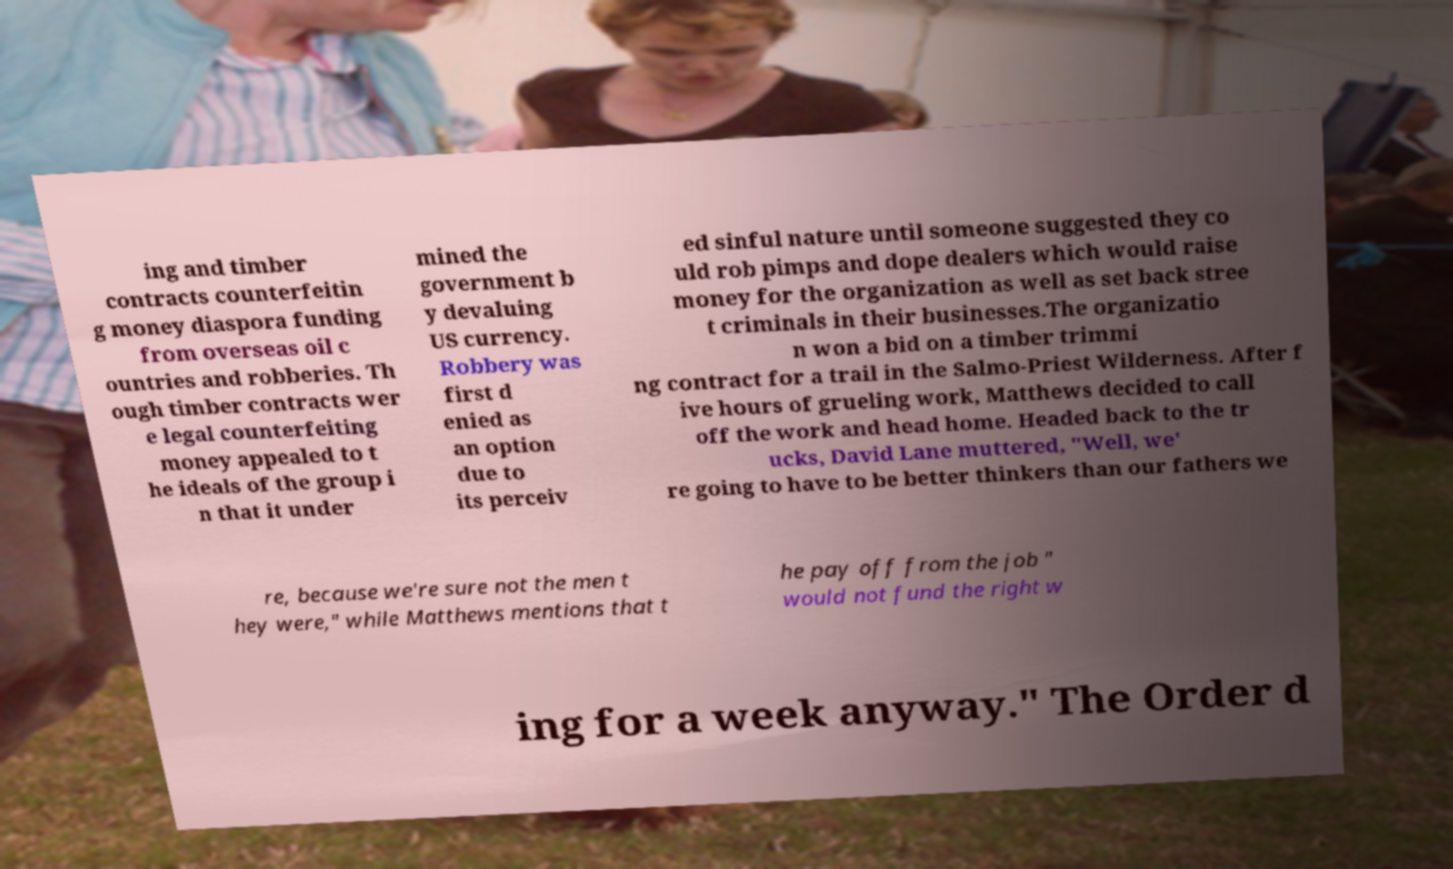Could you assist in decoding the text presented in this image and type it out clearly? ing and timber contracts counterfeitin g money diaspora funding from overseas oil c ountries and robberies. Th ough timber contracts wer e legal counterfeiting money appealed to t he ideals of the group i n that it under mined the government b y devaluing US currency. Robbery was first d enied as an option due to its perceiv ed sinful nature until someone suggested they co uld rob pimps and dope dealers which would raise money for the organization as well as set back stree t criminals in their businesses.The organizatio n won a bid on a timber trimmi ng contract for a trail in the Salmo-Priest Wilderness. After f ive hours of grueling work, Matthews decided to call off the work and head home. Headed back to the tr ucks, David Lane muttered, "Well, we' re going to have to be better thinkers than our fathers we re, because we're sure not the men t hey were," while Matthews mentions that t he pay off from the job " would not fund the right w ing for a week anyway." The Order d 